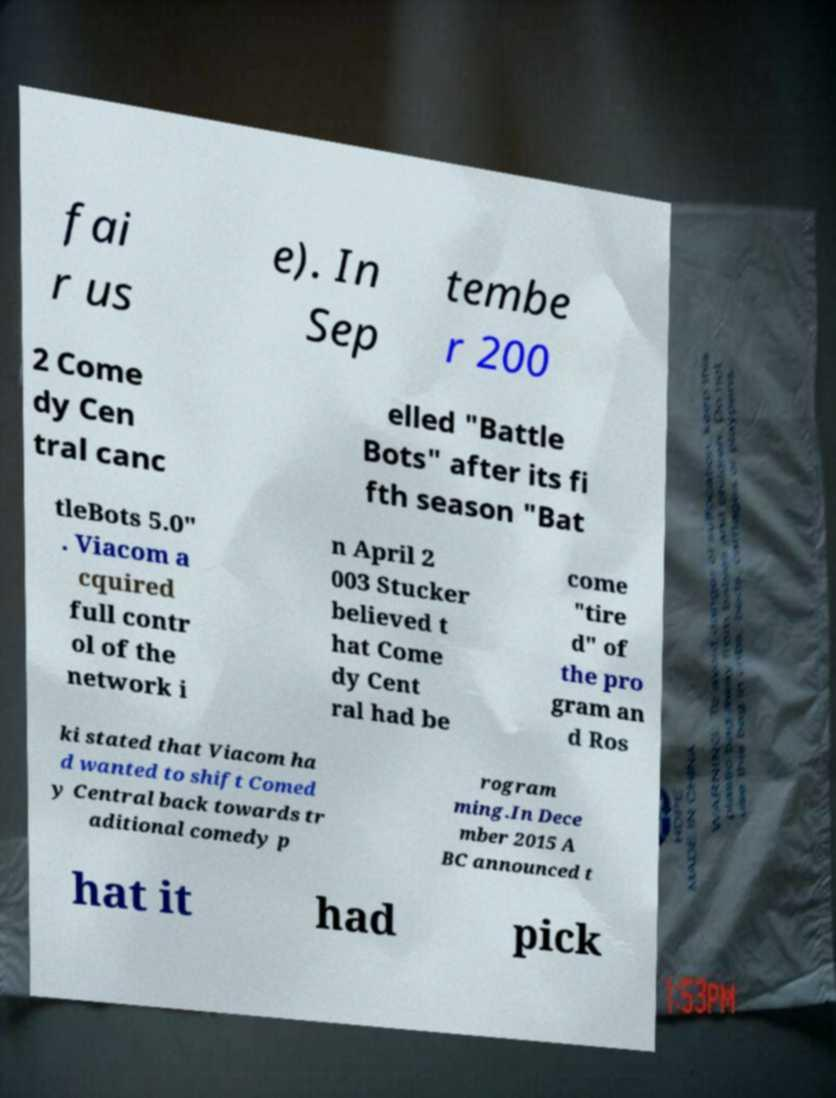For documentation purposes, I need the text within this image transcribed. Could you provide that? fai r us e). In Sep tembe r 200 2 Come dy Cen tral canc elled "Battle Bots" after its fi fth season "Bat tleBots 5.0" . Viacom a cquired full contr ol of the network i n April 2 003 Stucker believed t hat Come dy Cent ral had be come "tire d" of the pro gram an d Ros ki stated that Viacom ha d wanted to shift Comed y Central back towards tr aditional comedy p rogram ming.In Dece mber 2015 A BC announced t hat it had pick 